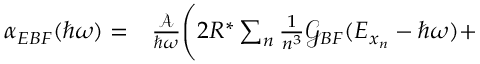Convert formula to latex. <formula><loc_0><loc_0><loc_500><loc_500>\begin{array} { r l } { \alpha _ { E B F } ( \hbar { \omega } ) = } & \frac { \mathcal { A } } { \hbar { \omega } } \Big ( 2 R ^ { * } \sum _ { n } \frac { 1 } { n ^ { 3 } } \mathcal { G } _ { B F } ( E _ { x _ { n } } - \hbar { \omega } ) + } \end{array}</formula> 